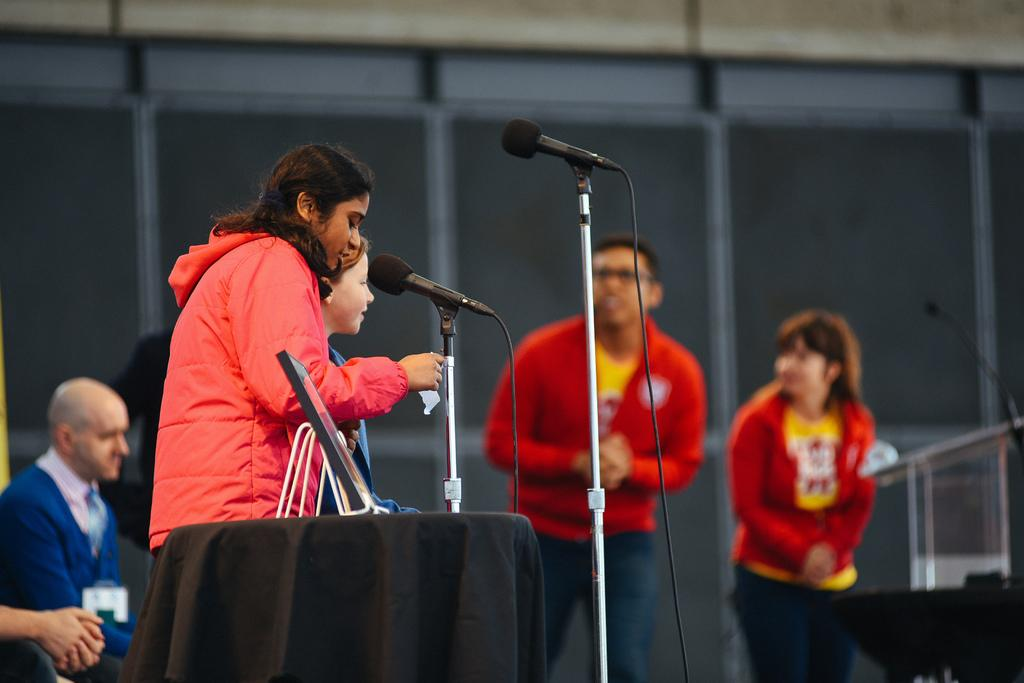Who or what can be seen in the image? There are people in the image. What object is on the table in the foreground area of the image? There is a frame on a table in the foreground area of the image. Can you describe the background of the image? There are other people, a mic, and windows in the background of the image. What type of crown is being worn by the person in the image? There is no crown present in the image. How is the comb being used by the person in the image? There is no comb present in the image. 